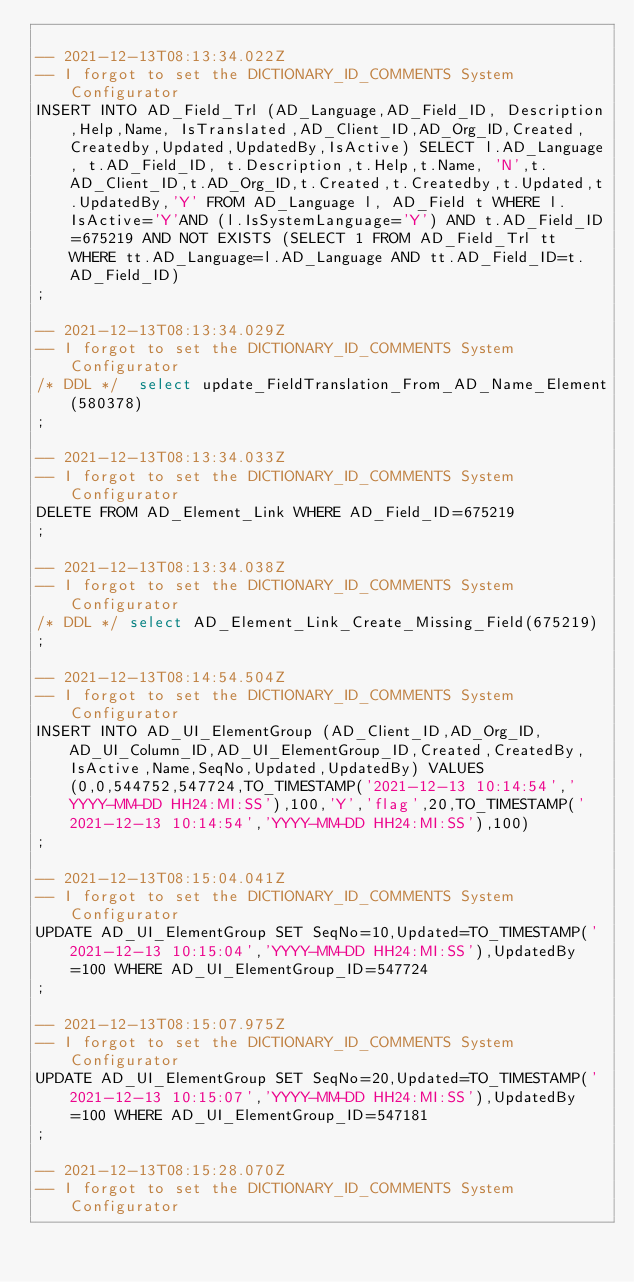Convert code to text. <code><loc_0><loc_0><loc_500><loc_500><_SQL_>
-- 2021-12-13T08:13:34.022Z
-- I forgot to set the DICTIONARY_ID_COMMENTS System Configurator
INSERT INTO AD_Field_Trl (AD_Language,AD_Field_ID, Description,Help,Name, IsTranslated,AD_Client_ID,AD_Org_ID,Created,Createdby,Updated,UpdatedBy,IsActive) SELECT l.AD_Language, t.AD_Field_ID, t.Description,t.Help,t.Name, 'N',t.AD_Client_ID,t.AD_Org_ID,t.Created,t.Createdby,t.Updated,t.UpdatedBy,'Y' FROM AD_Language l, AD_Field t WHERE l.IsActive='Y'AND (l.IsSystemLanguage='Y') AND t.AD_Field_ID=675219 AND NOT EXISTS (SELECT 1 FROM AD_Field_Trl tt WHERE tt.AD_Language=l.AD_Language AND tt.AD_Field_ID=t.AD_Field_ID)
;

-- 2021-12-13T08:13:34.029Z
-- I forgot to set the DICTIONARY_ID_COMMENTS System Configurator
/* DDL */  select update_FieldTranslation_From_AD_Name_Element(580378) 
;

-- 2021-12-13T08:13:34.033Z
-- I forgot to set the DICTIONARY_ID_COMMENTS System Configurator
DELETE FROM AD_Element_Link WHERE AD_Field_ID=675219
;

-- 2021-12-13T08:13:34.038Z
-- I forgot to set the DICTIONARY_ID_COMMENTS System Configurator
/* DDL */ select AD_Element_Link_Create_Missing_Field(675219)
;

-- 2021-12-13T08:14:54.504Z
-- I forgot to set the DICTIONARY_ID_COMMENTS System Configurator
INSERT INTO AD_UI_ElementGroup (AD_Client_ID,AD_Org_ID,AD_UI_Column_ID,AD_UI_ElementGroup_ID,Created,CreatedBy,IsActive,Name,SeqNo,Updated,UpdatedBy) VALUES (0,0,544752,547724,TO_TIMESTAMP('2021-12-13 10:14:54','YYYY-MM-DD HH24:MI:SS'),100,'Y','flag',20,TO_TIMESTAMP('2021-12-13 10:14:54','YYYY-MM-DD HH24:MI:SS'),100)
;

-- 2021-12-13T08:15:04.041Z
-- I forgot to set the DICTIONARY_ID_COMMENTS System Configurator
UPDATE AD_UI_ElementGroup SET SeqNo=10,Updated=TO_TIMESTAMP('2021-12-13 10:15:04','YYYY-MM-DD HH24:MI:SS'),UpdatedBy=100 WHERE AD_UI_ElementGroup_ID=547724
;

-- 2021-12-13T08:15:07.975Z
-- I forgot to set the DICTIONARY_ID_COMMENTS System Configurator
UPDATE AD_UI_ElementGroup SET SeqNo=20,Updated=TO_TIMESTAMP('2021-12-13 10:15:07','YYYY-MM-DD HH24:MI:SS'),UpdatedBy=100 WHERE AD_UI_ElementGroup_ID=547181
;

-- 2021-12-13T08:15:28.070Z
-- I forgot to set the DICTIONARY_ID_COMMENTS System Configurator</code> 